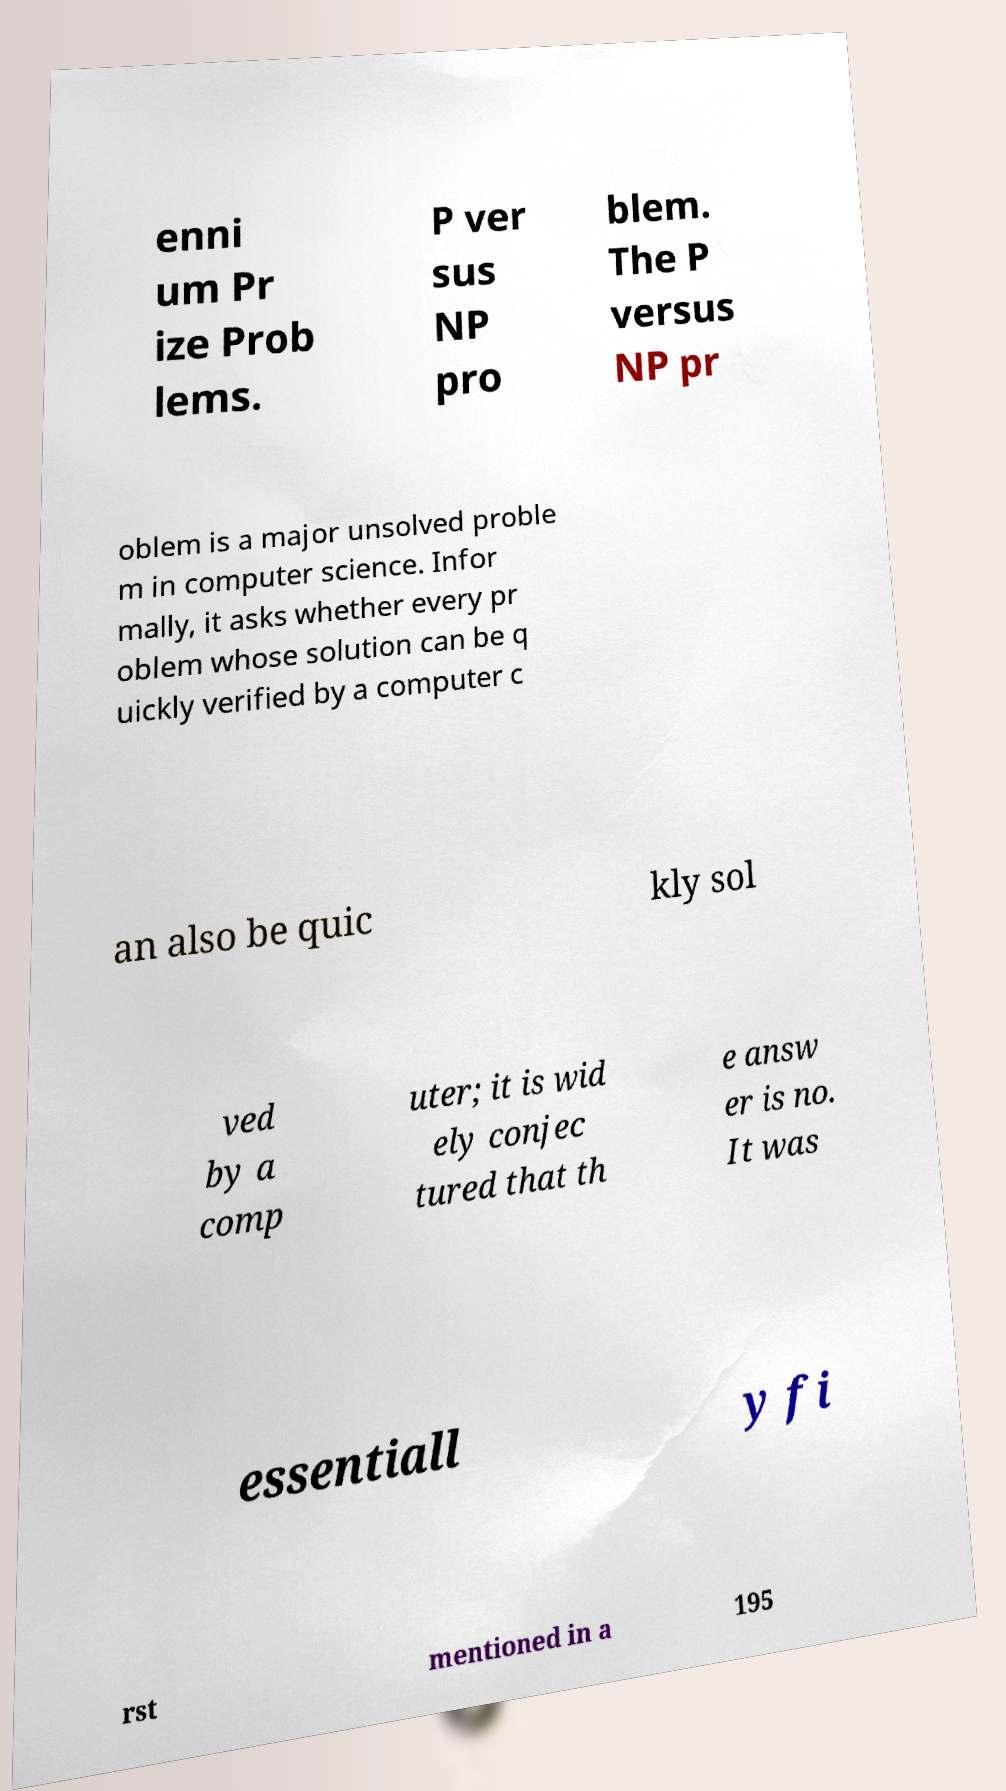There's text embedded in this image that I need extracted. Can you transcribe it verbatim? enni um Pr ize Prob lems. P ver sus NP pro blem. The P versus NP pr oblem is a major unsolved proble m in computer science. Infor mally, it asks whether every pr oblem whose solution can be q uickly verified by a computer c an also be quic kly sol ved by a comp uter; it is wid ely conjec tured that th e answ er is no. It was essentiall y fi rst mentioned in a 195 